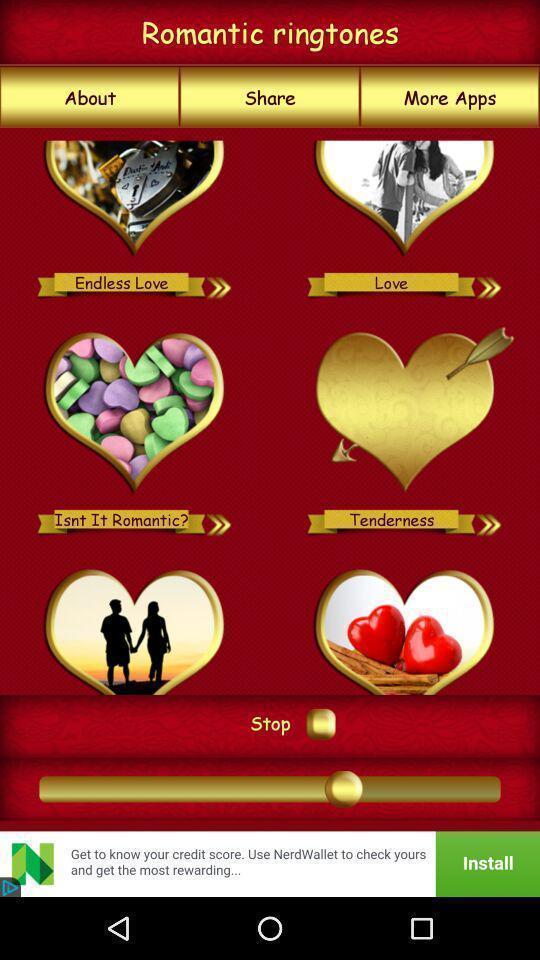Tell me what you see in this picture. Page showing ringtones. 